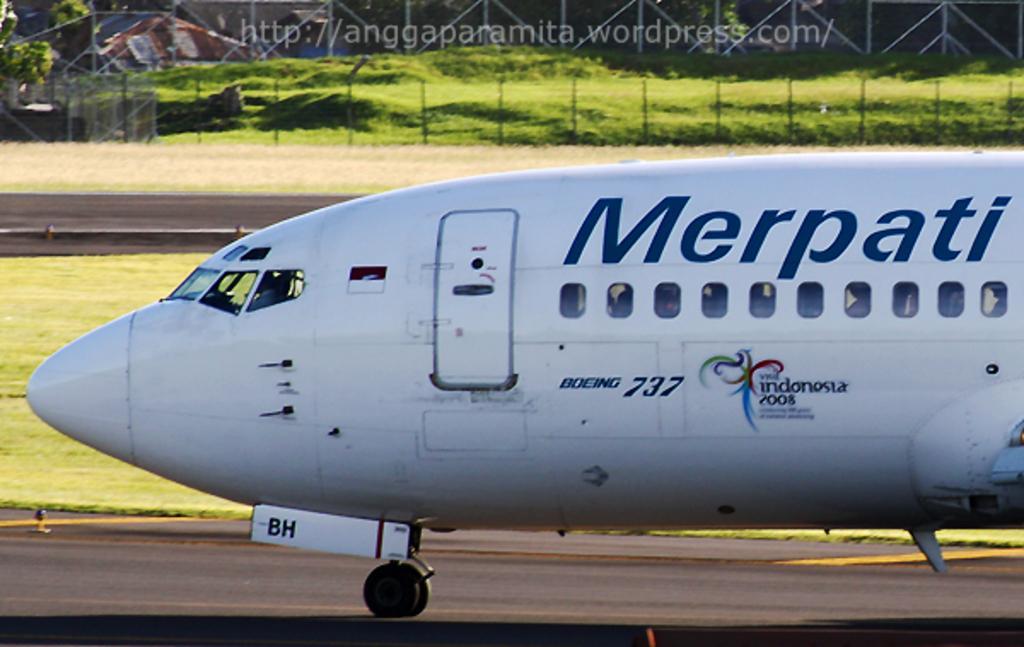Describe this image in one or two sentences. There is an airplane on the road. This is grass and there is a fence. In the background we can see trees. 